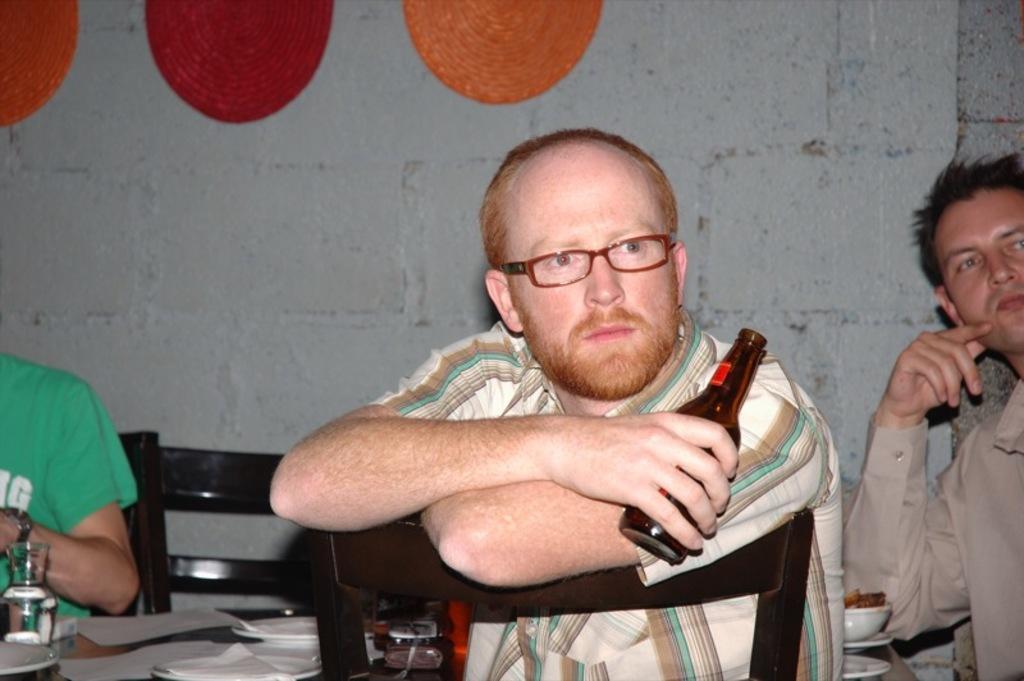How would you summarize this image in a sentence or two? In the middle of the image, there is a person sitting on the chair, holding a bottle in his hand and half visible. In the right bottom, a person half visible. In the left bottom, a person is sitting on the chair half visible in front of the table. In the background, a stone wall is there which is white in color. This image is taken inside a shop. 